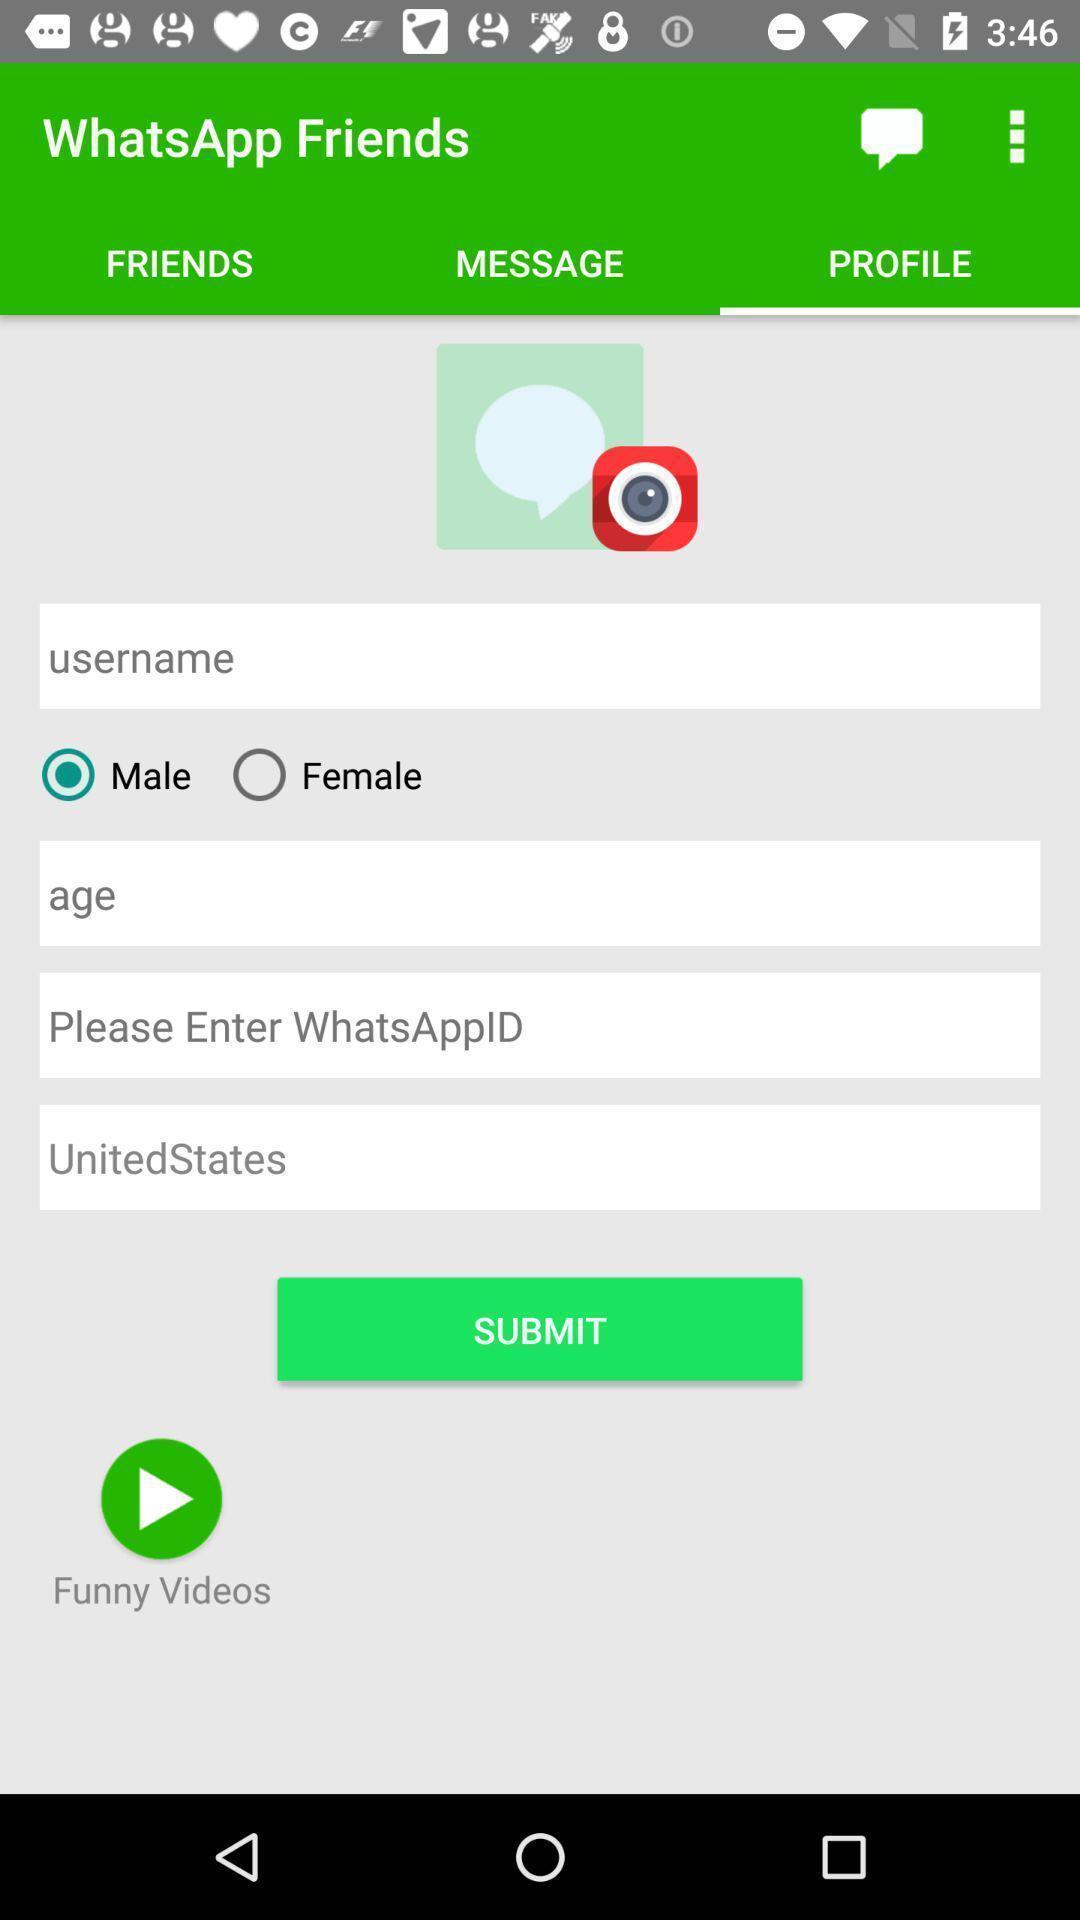What can you discern from this picture? Screen displaying user profile options in a social messenger application. 